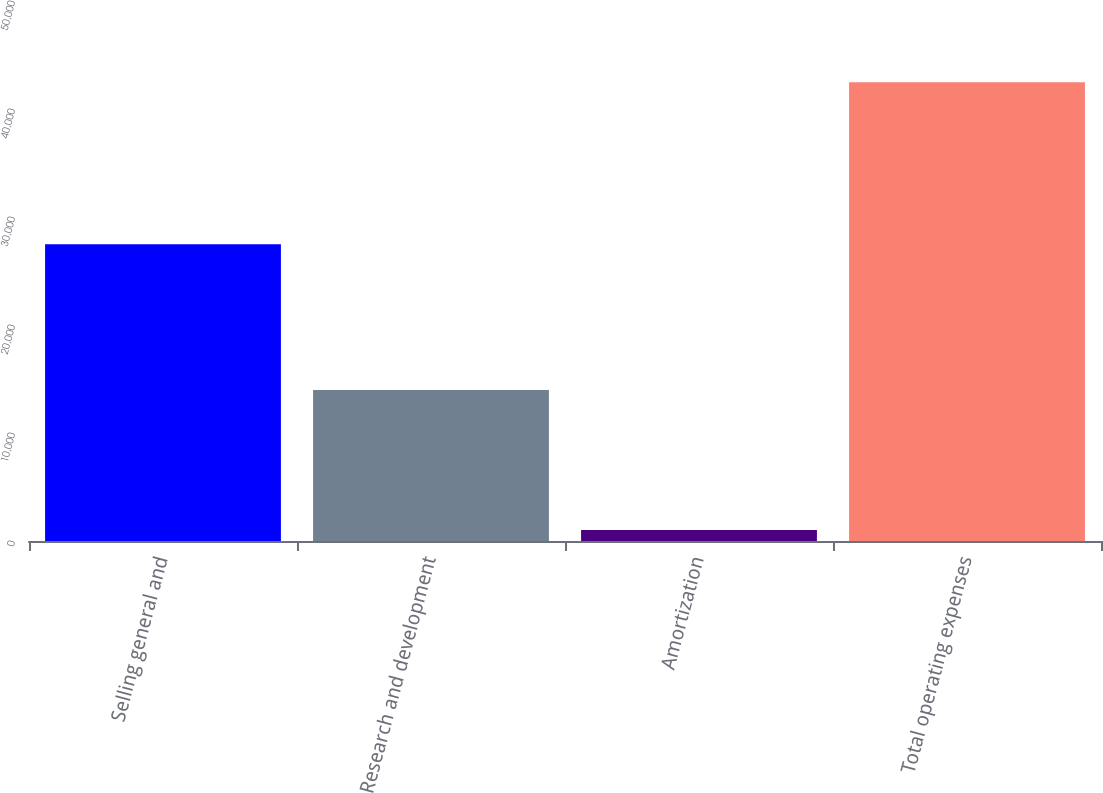Convert chart. <chart><loc_0><loc_0><loc_500><loc_500><bar_chart><fcel>Selling general and<fcel>Research and development<fcel>Amortization<fcel>Total operating expenses<nl><fcel>27469<fcel>13982<fcel>1029<fcel>42480<nl></chart> 